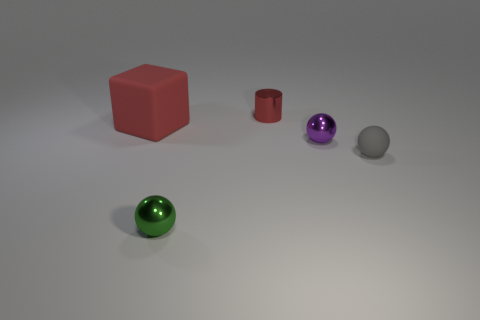Add 1 balls. How many objects exist? 6 Subtract all small rubber spheres. How many spheres are left? 2 Subtract 1 spheres. How many spheres are left? 2 Subtract all purple spheres. How many spheres are left? 2 Subtract all spheres. How many objects are left? 2 Subtract all tiny purple rubber objects. Subtract all small red cylinders. How many objects are left? 4 Add 3 cylinders. How many cylinders are left? 4 Add 4 spheres. How many spheres exist? 7 Subtract 1 red blocks. How many objects are left? 4 Subtract all green cylinders. Subtract all brown spheres. How many cylinders are left? 1 